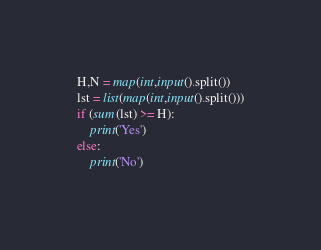Convert code to text. <code><loc_0><loc_0><loc_500><loc_500><_Python_>H,N = map(int,input().split())
lst = list(map(int,input().split()))
if (sum(lst) >= H):
    print('Yes')
else:
    print('No')</code> 